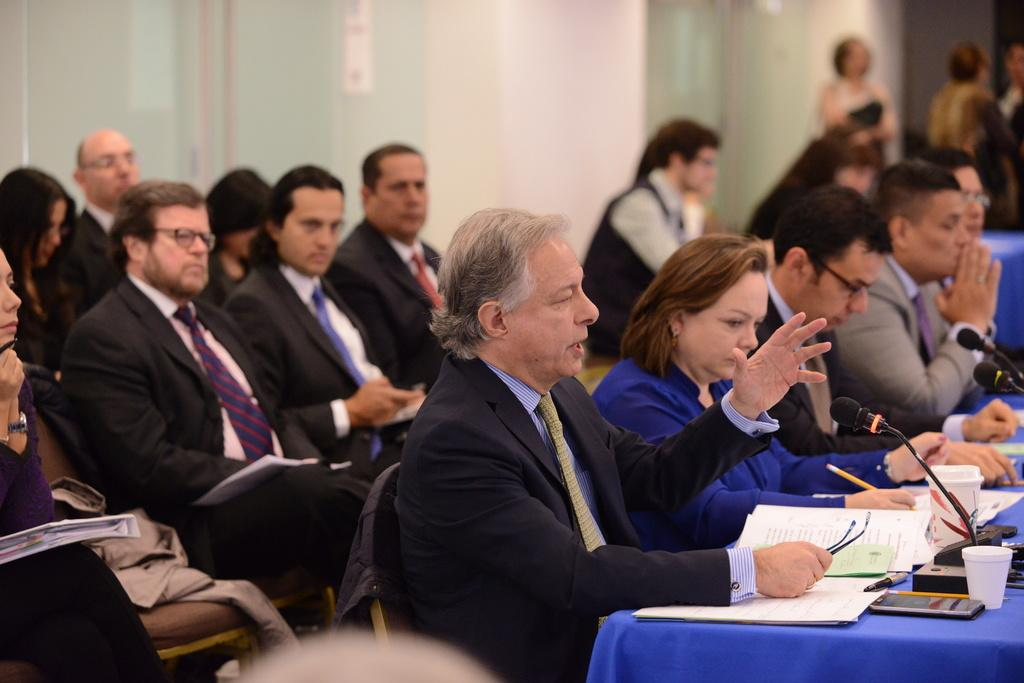What can be seen in the image? There are people, chairs, a table, microphones, cups, books, and other objects in the image. What might the people be using the microphones for? The microphones suggest that the people might be engaged in a discussion, presentation, or performance. What is the purpose of the cups in the image? The cups might be used for holding drinks or other beverages during the event. What can be inferred about the background of the image? The background of the image is blurred, which might indicate that the focus is on the people and objects in the foreground. What type of canvas is being painted by the doctor in the image? There is no doctor or canvas present in the image. How does the roll of paper contribute to the scene in the image? There is no roll of paper present in the image. 